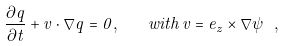<formula> <loc_0><loc_0><loc_500><loc_500>\frac { \partial q } { \partial t } + v \cdot \nabla q = 0 , \quad w i t h \, v = e _ { z } \times \nabla \psi \ ,</formula> 